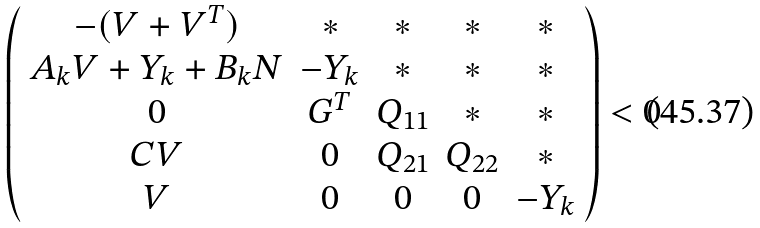Convert formula to latex. <formula><loc_0><loc_0><loc_500><loc_500>\left ( \begin{array} { c c c c c } - ( V + V ^ { T } ) & * & * & * & * \\ A _ { k } V + Y _ { k } + B _ { k } N & - Y _ { k } & * & * & * \\ 0 & G ^ { T } & Q _ { 1 1 } & * & * \\ C V & 0 & Q _ { 2 1 } & Q _ { 2 2 } & * \\ V & 0 & 0 & 0 & - Y _ { k } \end{array} \right ) < 0</formula> 